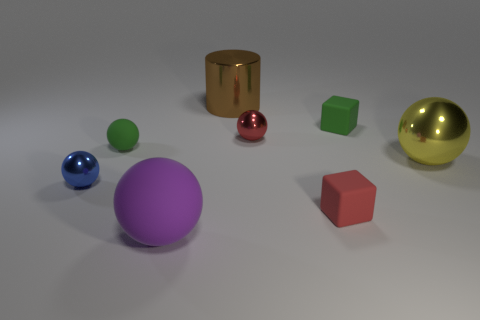There is a tiny cube that is the same color as the tiny rubber ball; what is it made of?
Ensure brevity in your answer.  Rubber. What number of brown things are either big rubber spheres or big cylinders?
Keep it short and to the point. 1. There is a tiny object that is the same material as the small blue sphere; what color is it?
Offer a very short reply. Red. Is there any other thing that is the same size as the brown cylinder?
Your answer should be very brief. Yes. How many small objects are blue things or brown metal things?
Keep it short and to the point. 1. Are there fewer tiny red things than big metallic cylinders?
Offer a terse response. No. There is another big thing that is the same shape as the big purple rubber object; what color is it?
Offer a terse response. Yellow. Are there any other things that have the same shape as the brown metal object?
Ensure brevity in your answer.  No. Are there more small green things than green matte balls?
Give a very brief answer. Yes. What number of other objects are the same material as the purple object?
Ensure brevity in your answer.  3. 